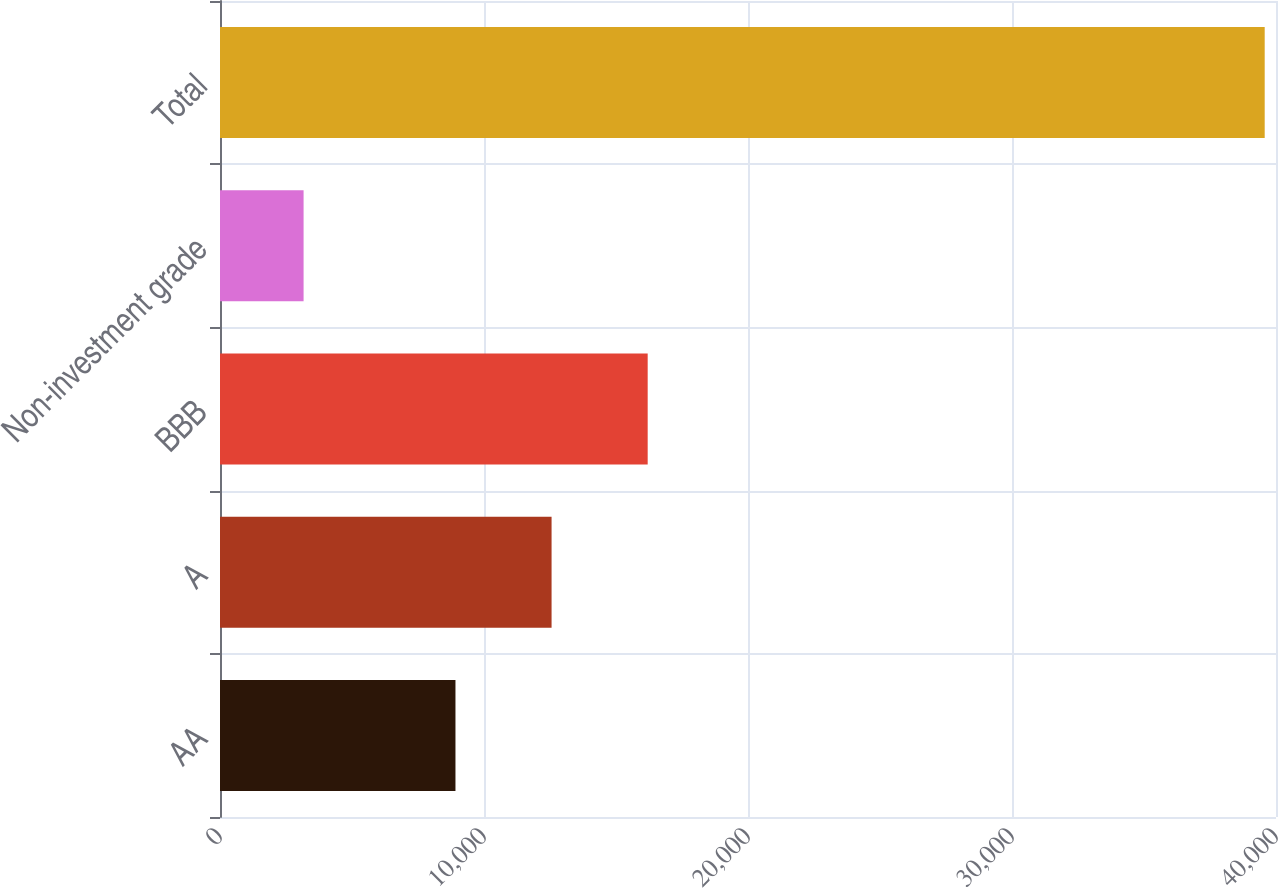Convert chart. <chart><loc_0><loc_0><loc_500><loc_500><bar_chart><fcel>AA<fcel>A<fcel>BBB<fcel>Non-investment grade<fcel>Total<nl><fcel>8919<fcel>12559.6<fcel>16200.2<fcel>3166<fcel>39572<nl></chart> 